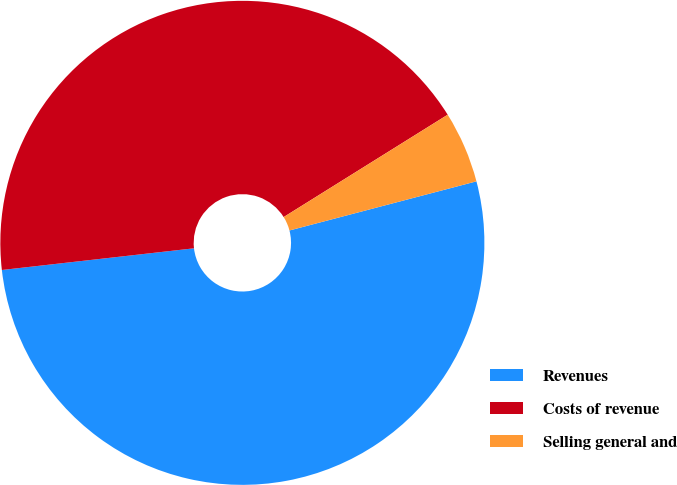<chart> <loc_0><loc_0><loc_500><loc_500><pie_chart><fcel>Revenues<fcel>Costs of revenue<fcel>Selling general and<nl><fcel>52.3%<fcel>42.91%<fcel>4.79%<nl></chart> 